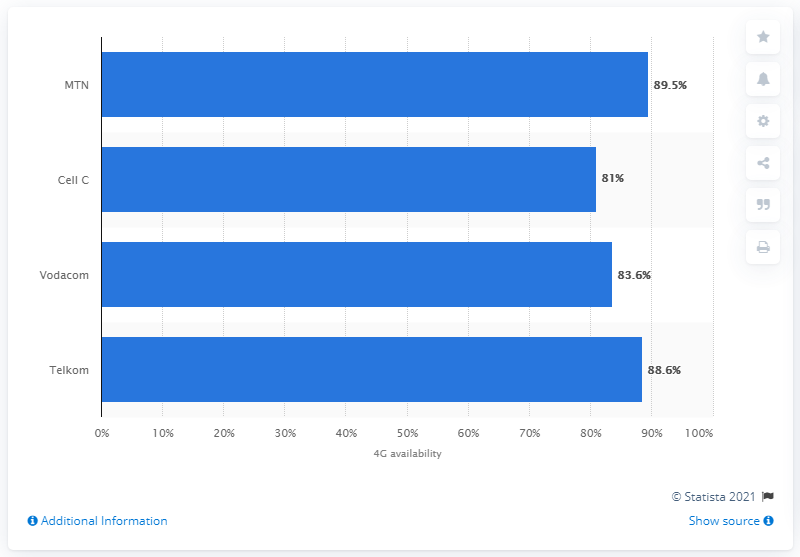Outline some significant characteristics in this image. MTN's availability rate was 89.5%. 